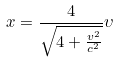<formula> <loc_0><loc_0><loc_500><loc_500>x = \frac { 4 } { \sqrt { 4 + \frac { v ^ { 2 } } { c ^ { 2 } } } } \upsilon</formula> 